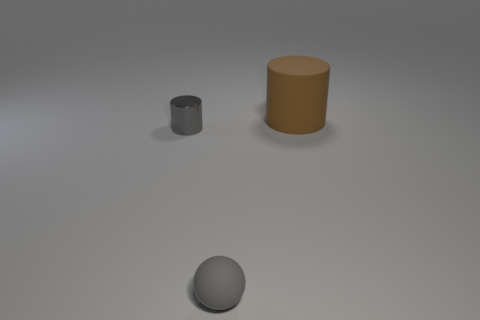What number of objects are objects that are to the right of the gray metallic thing or big brown rubber objects?
Provide a short and direct response. 2. Is the number of small gray objects left of the gray metallic object greater than the number of gray cylinders left of the tiny rubber ball?
Your answer should be very brief. No. Are the big cylinder and the gray cylinder made of the same material?
Offer a very short reply. No. The thing that is both on the left side of the large brown matte thing and on the right side of the gray cylinder has what shape?
Your response must be concise. Sphere. What shape is the tiny gray thing that is the same material as the large object?
Your answer should be very brief. Sphere. Are any things visible?
Keep it short and to the point. Yes. There is a matte object that is left of the big matte thing; are there any tiny cylinders on the left side of it?
Your answer should be very brief. Yes. What material is the other brown thing that is the same shape as the tiny metal object?
Ensure brevity in your answer.  Rubber. Are there more rubber spheres than small cyan blocks?
Offer a very short reply. Yes. Do the shiny thing and the thing behind the metallic object have the same color?
Your response must be concise. No. 